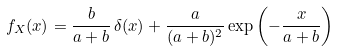Convert formula to latex. <formula><loc_0><loc_0><loc_500><loc_500>f _ { X } ( x ) = \frac { b } { a + b } \, \delta ( x ) + \frac { a } { ( a + b ) ^ { 2 } } \exp \left ( - \frac { x } { a + b } \right )</formula> 